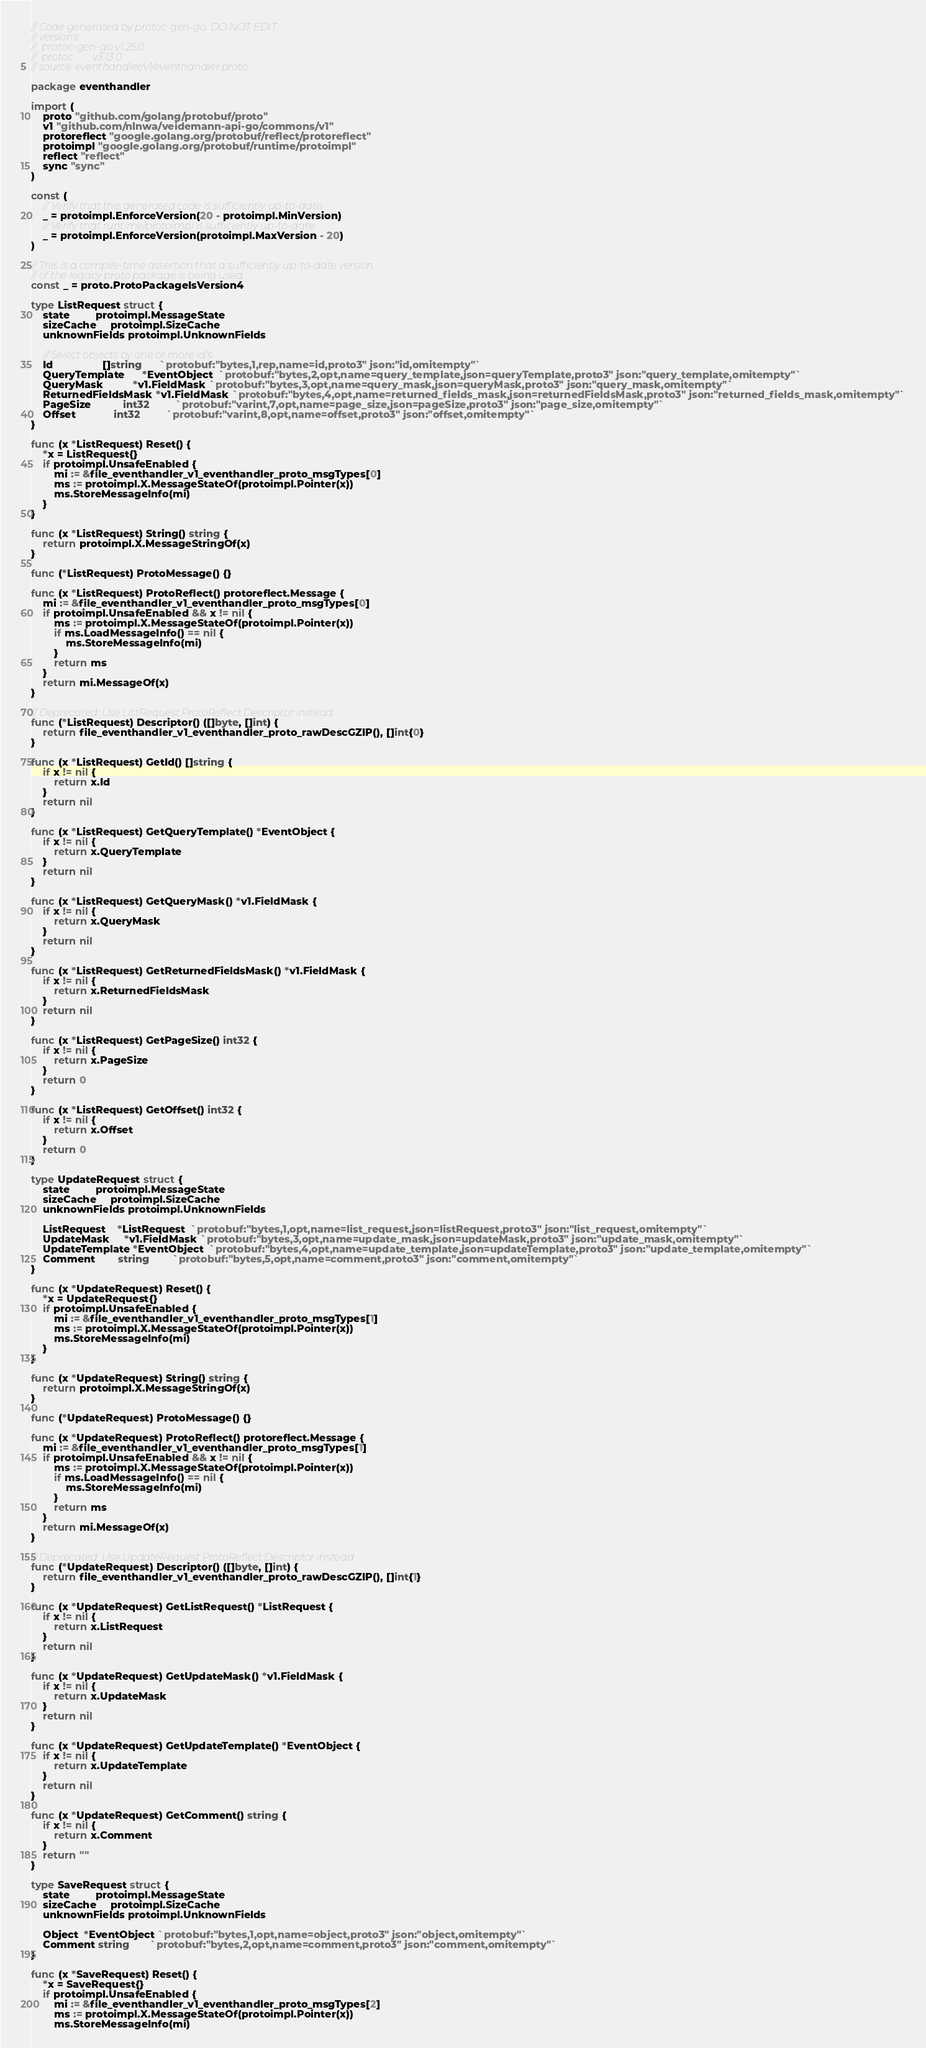<code> <loc_0><loc_0><loc_500><loc_500><_Go_>// Code generated by protoc-gen-go. DO NOT EDIT.
// versions:
// 	protoc-gen-go v1.25.0
// 	protoc        v3.13.0
// source: eventhandler/v1/eventhandler.proto

package eventhandler

import (
	proto "github.com/golang/protobuf/proto"
	v1 "github.com/nlnwa/veidemann-api-go/commons/v1"
	protoreflect "google.golang.org/protobuf/reflect/protoreflect"
	protoimpl "google.golang.org/protobuf/runtime/protoimpl"
	reflect "reflect"
	sync "sync"
)

const (
	// Verify that this generated code is sufficiently up-to-date.
	_ = protoimpl.EnforceVersion(20 - protoimpl.MinVersion)
	// Verify that runtime/protoimpl is sufficiently up-to-date.
	_ = protoimpl.EnforceVersion(protoimpl.MaxVersion - 20)
)

// This is a compile-time assertion that a sufficiently up-to-date version
// of the legacy proto package is being used.
const _ = proto.ProtoPackageIsVersion4

type ListRequest struct {
	state         protoimpl.MessageState
	sizeCache     protoimpl.SizeCache
	unknownFields protoimpl.UnknownFields

	// Select objects by one or more id's
	Id                 []string      `protobuf:"bytes,1,rep,name=id,proto3" json:"id,omitempty"`
	QueryTemplate      *EventObject  `protobuf:"bytes,2,opt,name=query_template,json=queryTemplate,proto3" json:"query_template,omitempty"`
	QueryMask          *v1.FieldMask `protobuf:"bytes,3,opt,name=query_mask,json=queryMask,proto3" json:"query_mask,omitempty"`
	ReturnedFieldsMask *v1.FieldMask `protobuf:"bytes,4,opt,name=returned_fields_mask,json=returnedFieldsMask,proto3" json:"returned_fields_mask,omitempty"`
	PageSize           int32         `protobuf:"varint,7,opt,name=page_size,json=pageSize,proto3" json:"page_size,omitempty"`
	Offset             int32         `protobuf:"varint,8,opt,name=offset,proto3" json:"offset,omitempty"`
}

func (x *ListRequest) Reset() {
	*x = ListRequest{}
	if protoimpl.UnsafeEnabled {
		mi := &file_eventhandler_v1_eventhandler_proto_msgTypes[0]
		ms := protoimpl.X.MessageStateOf(protoimpl.Pointer(x))
		ms.StoreMessageInfo(mi)
	}
}

func (x *ListRequest) String() string {
	return protoimpl.X.MessageStringOf(x)
}

func (*ListRequest) ProtoMessage() {}

func (x *ListRequest) ProtoReflect() protoreflect.Message {
	mi := &file_eventhandler_v1_eventhandler_proto_msgTypes[0]
	if protoimpl.UnsafeEnabled && x != nil {
		ms := protoimpl.X.MessageStateOf(protoimpl.Pointer(x))
		if ms.LoadMessageInfo() == nil {
			ms.StoreMessageInfo(mi)
		}
		return ms
	}
	return mi.MessageOf(x)
}

// Deprecated: Use ListRequest.ProtoReflect.Descriptor instead.
func (*ListRequest) Descriptor() ([]byte, []int) {
	return file_eventhandler_v1_eventhandler_proto_rawDescGZIP(), []int{0}
}

func (x *ListRequest) GetId() []string {
	if x != nil {
		return x.Id
	}
	return nil
}

func (x *ListRequest) GetQueryTemplate() *EventObject {
	if x != nil {
		return x.QueryTemplate
	}
	return nil
}

func (x *ListRequest) GetQueryMask() *v1.FieldMask {
	if x != nil {
		return x.QueryMask
	}
	return nil
}

func (x *ListRequest) GetReturnedFieldsMask() *v1.FieldMask {
	if x != nil {
		return x.ReturnedFieldsMask
	}
	return nil
}

func (x *ListRequest) GetPageSize() int32 {
	if x != nil {
		return x.PageSize
	}
	return 0
}

func (x *ListRequest) GetOffset() int32 {
	if x != nil {
		return x.Offset
	}
	return 0
}

type UpdateRequest struct {
	state         protoimpl.MessageState
	sizeCache     protoimpl.SizeCache
	unknownFields protoimpl.UnknownFields

	ListRequest    *ListRequest  `protobuf:"bytes,1,opt,name=list_request,json=listRequest,proto3" json:"list_request,omitempty"`
	UpdateMask     *v1.FieldMask `protobuf:"bytes,3,opt,name=update_mask,json=updateMask,proto3" json:"update_mask,omitempty"`
	UpdateTemplate *EventObject  `protobuf:"bytes,4,opt,name=update_template,json=updateTemplate,proto3" json:"update_template,omitempty"`
	Comment        string        `protobuf:"bytes,5,opt,name=comment,proto3" json:"comment,omitempty"`
}

func (x *UpdateRequest) Reset() {
	*x = UpdateRequest{}
	if protoimpl.UnsafeEnabled {
		mi := &file_eventhandler_v1_eventhandler_proto_msgTypes[1]
		ms := protoimpl.X.MessageStateOf(protoimpl.Pointer(x))
		ms.StoreMessageInfo(mi)
	}
}

func (x *UpdateRequest) String() string {
	return protoimpl.X.MessageStringOf(x)
}

func (*UpdateRequest) ProtoMessage() {}

func (x *UpdateRequest) ProtoReflect() protoreflect.Message {
	mi := &file_eventhandler_v1_eventhandler_proto_msgTypes[1]
	if protoimpl.UnsafeEnabled && x != nil {
		ms := protoimpl.X.MessageStateOf(protoimpl.Pointer(x))
		if ms.LoadMessageInfo() == nil {
			ms.StoreMessageInfo(mi)
		}
		return ms
	}
	return mi.MessageOf(x)
}

// Deprecated: Use UpdateRequest.ProtoReflect.Descriptor instead.
func (*UpdateRequest) Descriptor() ([]byte, []int) {
	return file_eventhandler_v1_eventhandler_proto_rawDescGZIP(), []int{1}
}

func (x *UpdateRequest) GetListRequest() *ListRequest {
	if x != nil {
		return x.ListRequest
	}
	return nil
}

func (x *UpdateRequest) GetUpdateMask() *v1.FieldMask {
	if x != nil {
		return x.UpdateMask
	}
	return nil
}

func (x *UpdateRequest) GetUpdateTemplate() *EventObject {
	if x != nil {
		return x.UpdateTemplate
	}
	return nil
}

func (x *UpdateRequest) GetComment() string {
	if x != nil {
		return x.Comment
	}
	return ""
}

type SaveRequest struct {
	state         protoimpl.MessageState
	sizeCache     protoimpl.SizeCache
	unknownFields protoimpl.UnknownFields

	Object  *EventObject `protobuf:"bytes,1,opt,name=object,proto3" json:"object,omitempty"`
	Comment string       `protobuf:"bytes,2,opt,name=comment,proto3" json:"comment,omitempty"`
}

func (x *SaveRequest) Reset() {
	*x = SaveRequest{}
	if protoimpl.UnsafeEnabled {
		mi := &file_eventhandler_v1_eventhandler_proto_msgTypes[2]
		ms := protoimpl.X.MessageStateOf(protoimpl.Pointer(x))
		ms.StoreMessageInfo(mi)</code> 